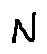Convert formula to latex. <formula><loc_0><loc_0><loc_500><loc_500>N</formula> 